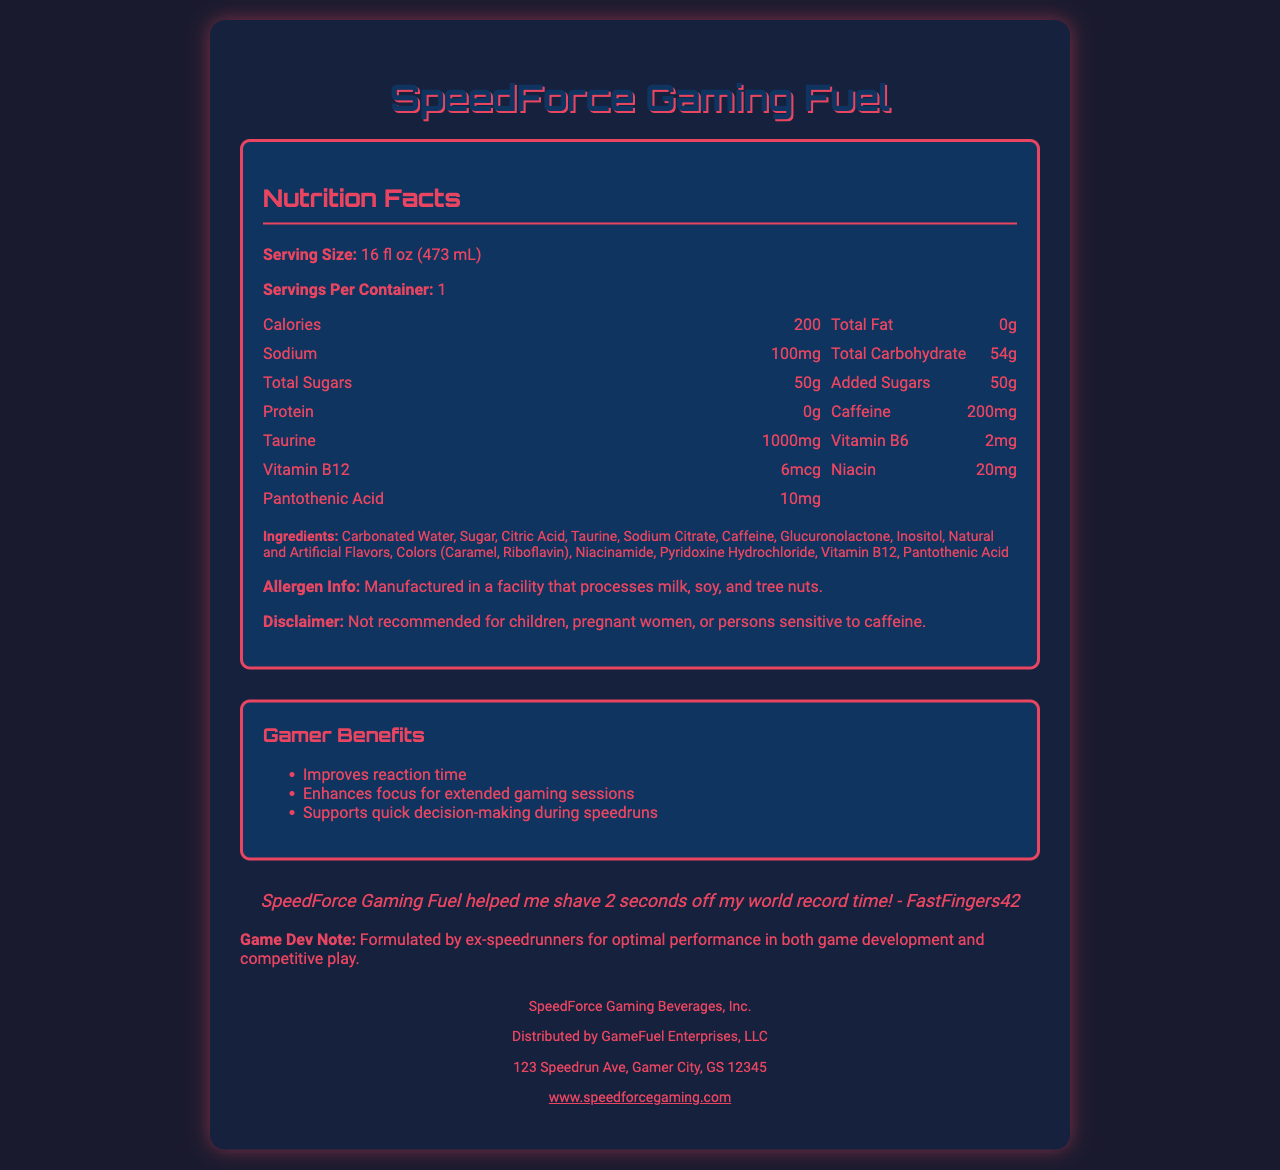how many calories are in one serving of SpeedForce Gaming Fuel? The document lists the calories as 200 per serving.
Answer: 200 calories what is the caffeine content in SpeedForce Gaming Fuel? The document states the caffeine content is 200mg per serving.
Answer: 200mg how much taurine is in a serving of SpeedForce Gaming Fuel? The taurine content per serving is listed as 1000mg in the document.
Answer: 1000mg how many grams of sugar are in a serving of SpeedForce Gaming Fuel? The document specifies that there are 50 grams of total sugars per serving.
Answer: 50g what is the serving size of SpeedForce Gaming Fuel? The serving size is specified as 16 fl oz (473 mL) in the document.
Answer: 16 fl oz (473 mL) which vitamins are included in SpeedForce Gaming Fuel? A. Vitamin D and Calcium B. Vitamin B6 and B12 C. Vitamin C and Iron The document lists Vitamin B6 (2mg) and Vitamin B12 (6mcg).
Answer: B. Vitamin B6 and B12 what is the total carbohydrate content per serving of SpeedForce Gaming Fuel? A. 40g B. 54g C. 60g The document indicates that the total carbohydrate content is 54g per serving.
Answer: B. 54g does SpeedForce Gaming Fuel contain any protein? The nutrition facts state that there is 0g of protein per serving.
Answer: No, 0g was this product tested by speedrunners? The testimonial from a speedrunner named FastFingers42 and the game dev note mention the product was formulated by ex-speedrunners.
Answer: Yes where is the manufacturer located? The address provided for the manufacturer is 123 Speedrun Ave, Gamer City, GS 12345.
Answer: 123 Speedrun Ave, Gamer City, GS 12345 what is the purpose of consuming SpeedForce Gaming Fuel as stated in the document? The gamer benefits section lists these as the advantages of consuming the drink.
Answer: Improves reaction time, Enhances focus for extended gaming sessions, Supports quick decision-making during speedruns does the document provide the exact milligrams of caffeine and taurine? The nutritional information specifies 200mg of caffeine and 1000mg of taurine.
Answer: Yes describe the main features of the SpeedForce Gaming Fuel document. The document comprehensively covers nutritional content, ingredients, benefits, safety information, and endorsements for SpeedForce Gaming Fuel.
Answer: The document provides a detailed Nutrition Facts Label for SpeedForce Gaming Fuel, including information on serving size, calories, fat, sodium, carbohydrates, sugars, proteins, caffeine, taurine, and various vitamins. It also lists ingredients, allergen information, a disclaimer about who should avoid this product, the manufacturer and distributor's details, gamer benefits, and testimonials from users and game developers. who is the distributor of SpeedForce Gaming Fuel? The document states that the product is distributed by GameFuel Enterprises, LLC.
Answer: GameFuel Enterprises, LLC can pregnant women safely consume SpeedForce Gaming Fuel? The disclaimer explicitly states that it is not recommended for children, pregnant women, or persons sensitive to caffeine.
Answer: No what specific benefit does FastFingers42 claim from using SpeedForce Gaming Fuel? The testimonial states FastFingers42 was able to shave 2 seconds off their world record time.
Answer: Shaved 2 seconds off world record time how much sodium is in one serving of SpeedForce Gaming Fuel? The document lists the sodium content as 100mg per serving.
Answer: 100mg what is the website for more information about SpeedForce Gaming Fuel? The website provided in the document is www.speedforcegaming.com.
Answer: www.speedforcegaming.com how much pantothenic acid is in each serving? The document indicates there is 10mg of pantothenic acid per serving.
Answer: 10mg what is the scientific name for Vitamin B6 as listed in the ingredients? The ingredients list includes Pyridoxine Hydrochloride, which is the scientific name for Vitamin B6.
Answer: Pyridoxine Hydrochloride how many calories does one container of SpeedForce Gaming Fuel provide? Since there is 1 serving per container and each serving has 200 calories, one container has 200 calories.
Answer: 200 calories how much glucuronolactone does one serving contain? The document lists glucuronolactone as an ingredient but does not specify the amount in this drink.
Answer: Not specified 